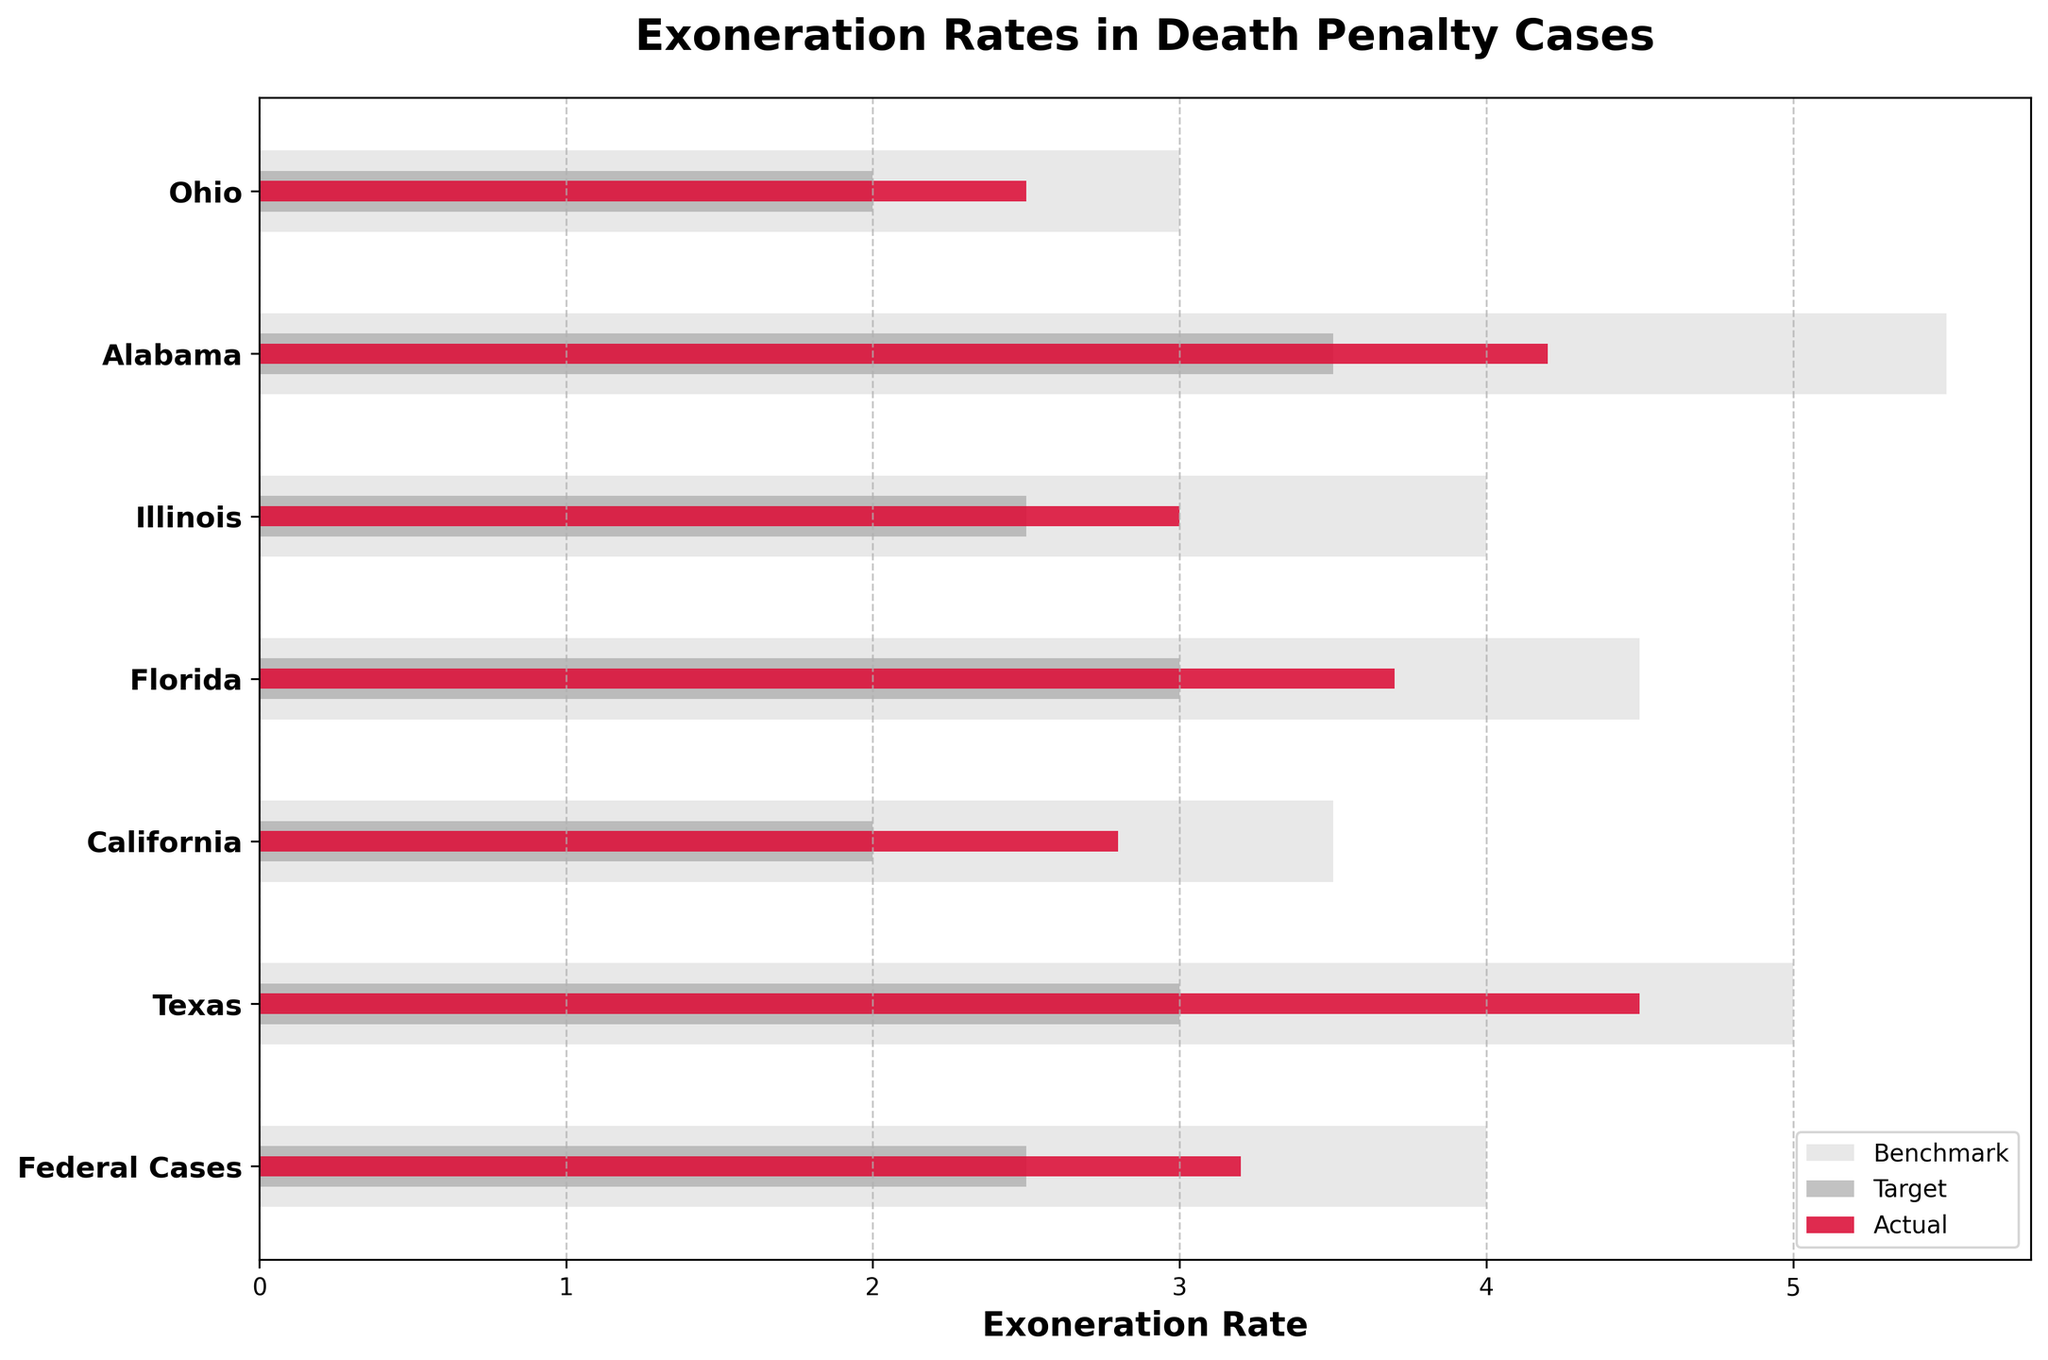How many categories are represented in the figure? The y-axis labels indicate the number of categories. Counting them gives the total number.
Answer: 7 What is the title of the figure? The title is prominently displayed at the top of the plot.
Answer: Exoneration Rates in Death Penalty Cases Which category has the highest actual exoneration rate? By comparing the red bars (actual values) across all categories, the longest red bar indicates the highest rate.
Answer: Texas What is the difference between the actual and target exoneration rate for California? Subtract the target rate from the actual rate for California found in their respective bars. The actual is 2.8, and the target is 2.0.
Answer: 0.8 Are there any categories where the actual rate exceeds the benchmark? By visually comparing the red bars (actual) and gray bars (benchmark) for each category, it appears that none of the red bars surpasses the gray ones.
Answer: No Which categories meet or exceed their target exoneration rates? Compare the red bars (actual values) to their corresponding dark gray bars (target values). Categories where the red bar is equal to or longer than the gray bar meet or exceed the target.
Answer: Federal Cases, Texas, Florida, Alabama In which category is the difference between the benchmark and actual exoneration rate the smallest? Calculate the difference (benchmark - actual) for each category, then identify the smallest value.
Answer: Ohio (3.0 - 2.5 = 0.5) What is the average target exoneration rate across all categories? Add all the target rates together and divide by the number of categories (7). The rates are 2.5, 3.0, 2.0, 3.0, 2.5, 3.5, and 2.0. Sum = 18.5; 18.5 / 7 = 2.64
Answer: 2.64 Which category has the largest discrepancy between the actual and benchmark rates? Calculate the absolute difference (benchmark - actual) for each category, then find the largest value.
Answer: Alabama (5.5 - 4.2 = 1.3) What is the expected exoneration rate target for federal cases? Refer to the dark gray bar length for the "Federal Cases" category.
Answer: 2.5 